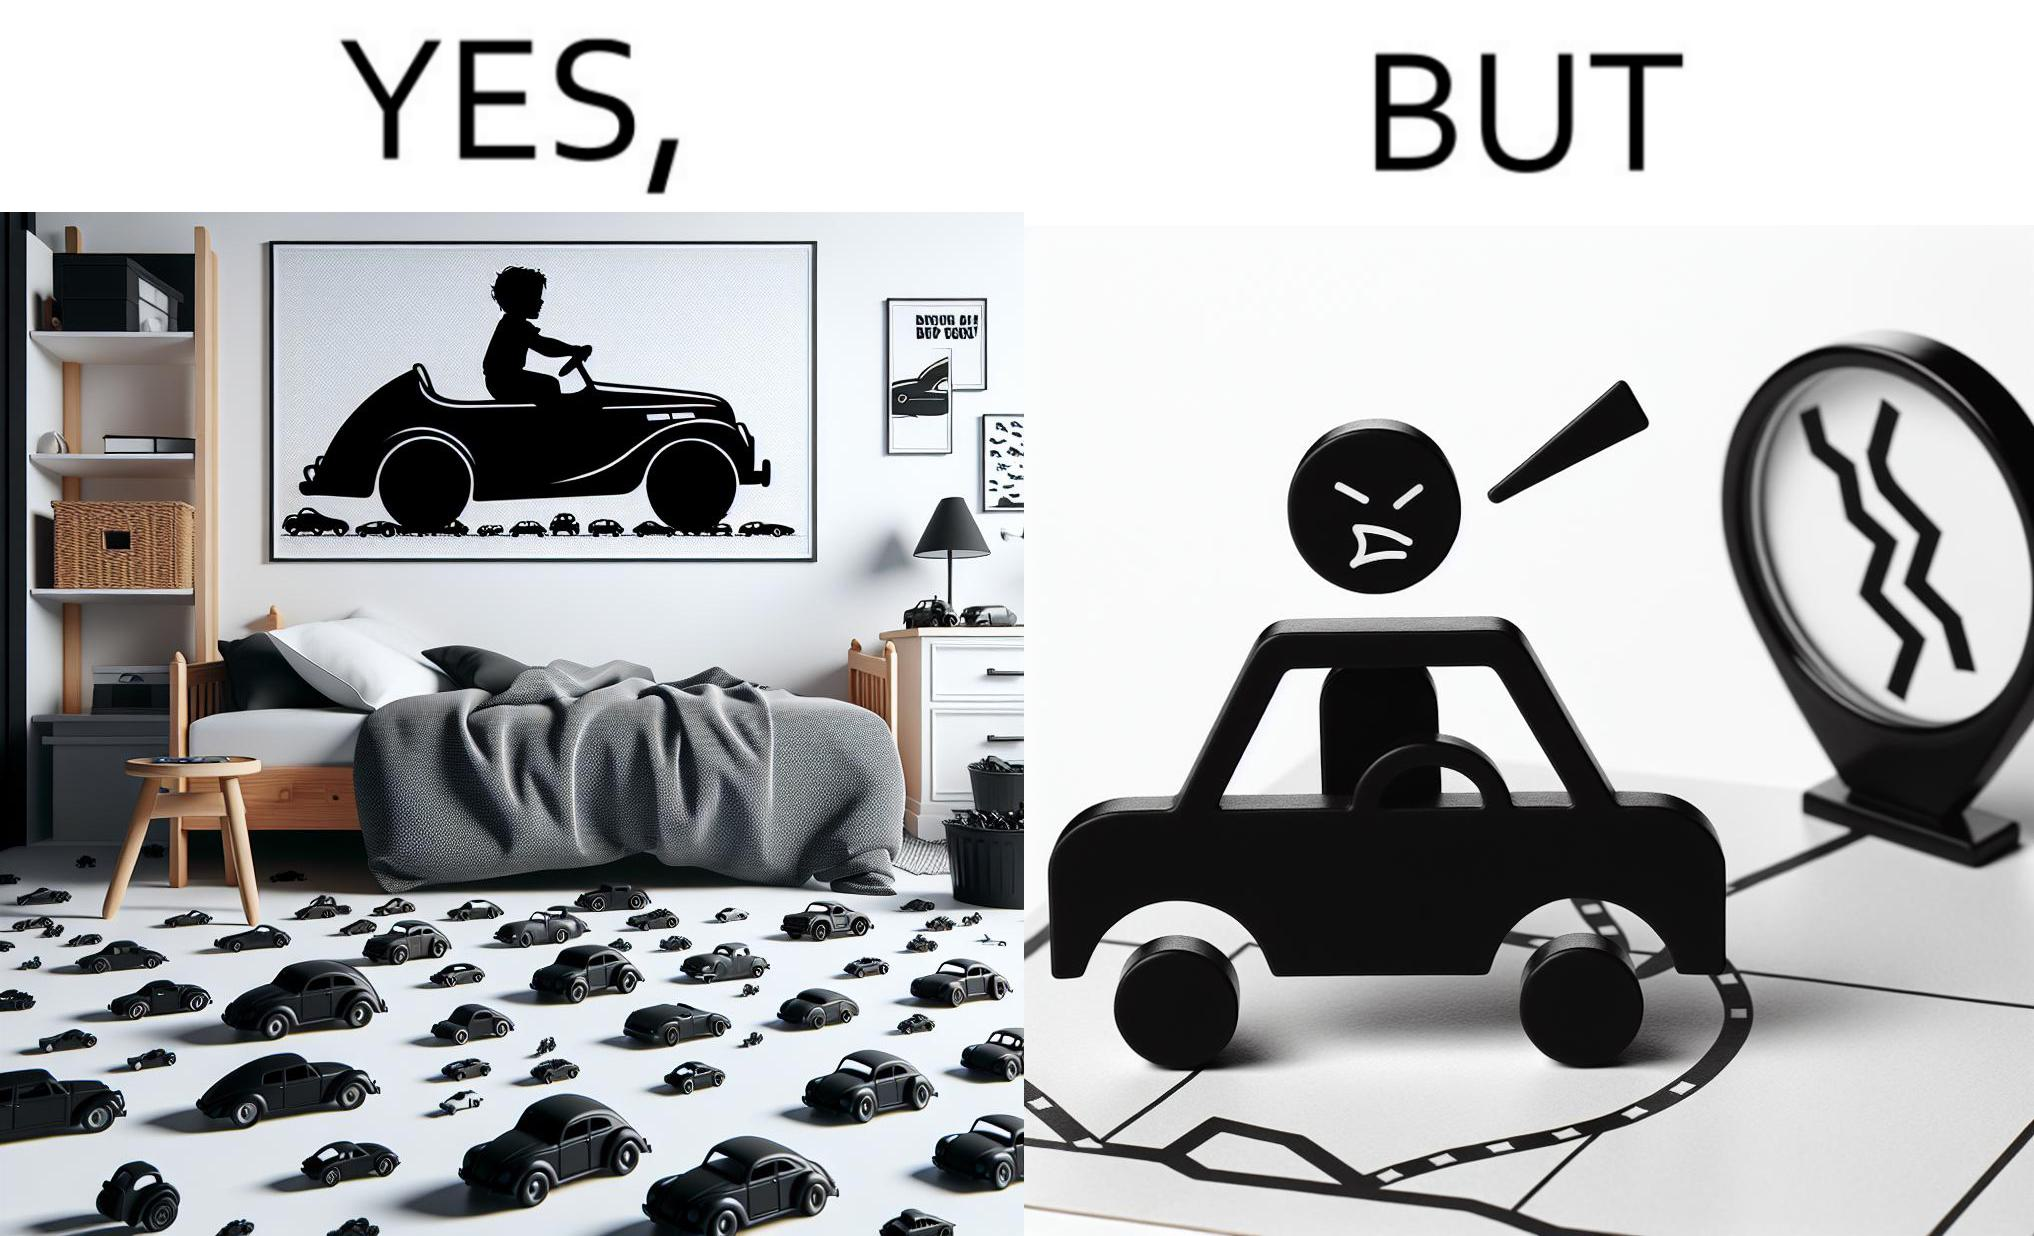What is the satirical meaning behind this image? The image is funny beaucse while the person as a child enjoyed being around cars, had various small toy cars and even rode a bigger toy car, as as grown up he does not enjoy being in a car during a traffic jam while he is driving . 